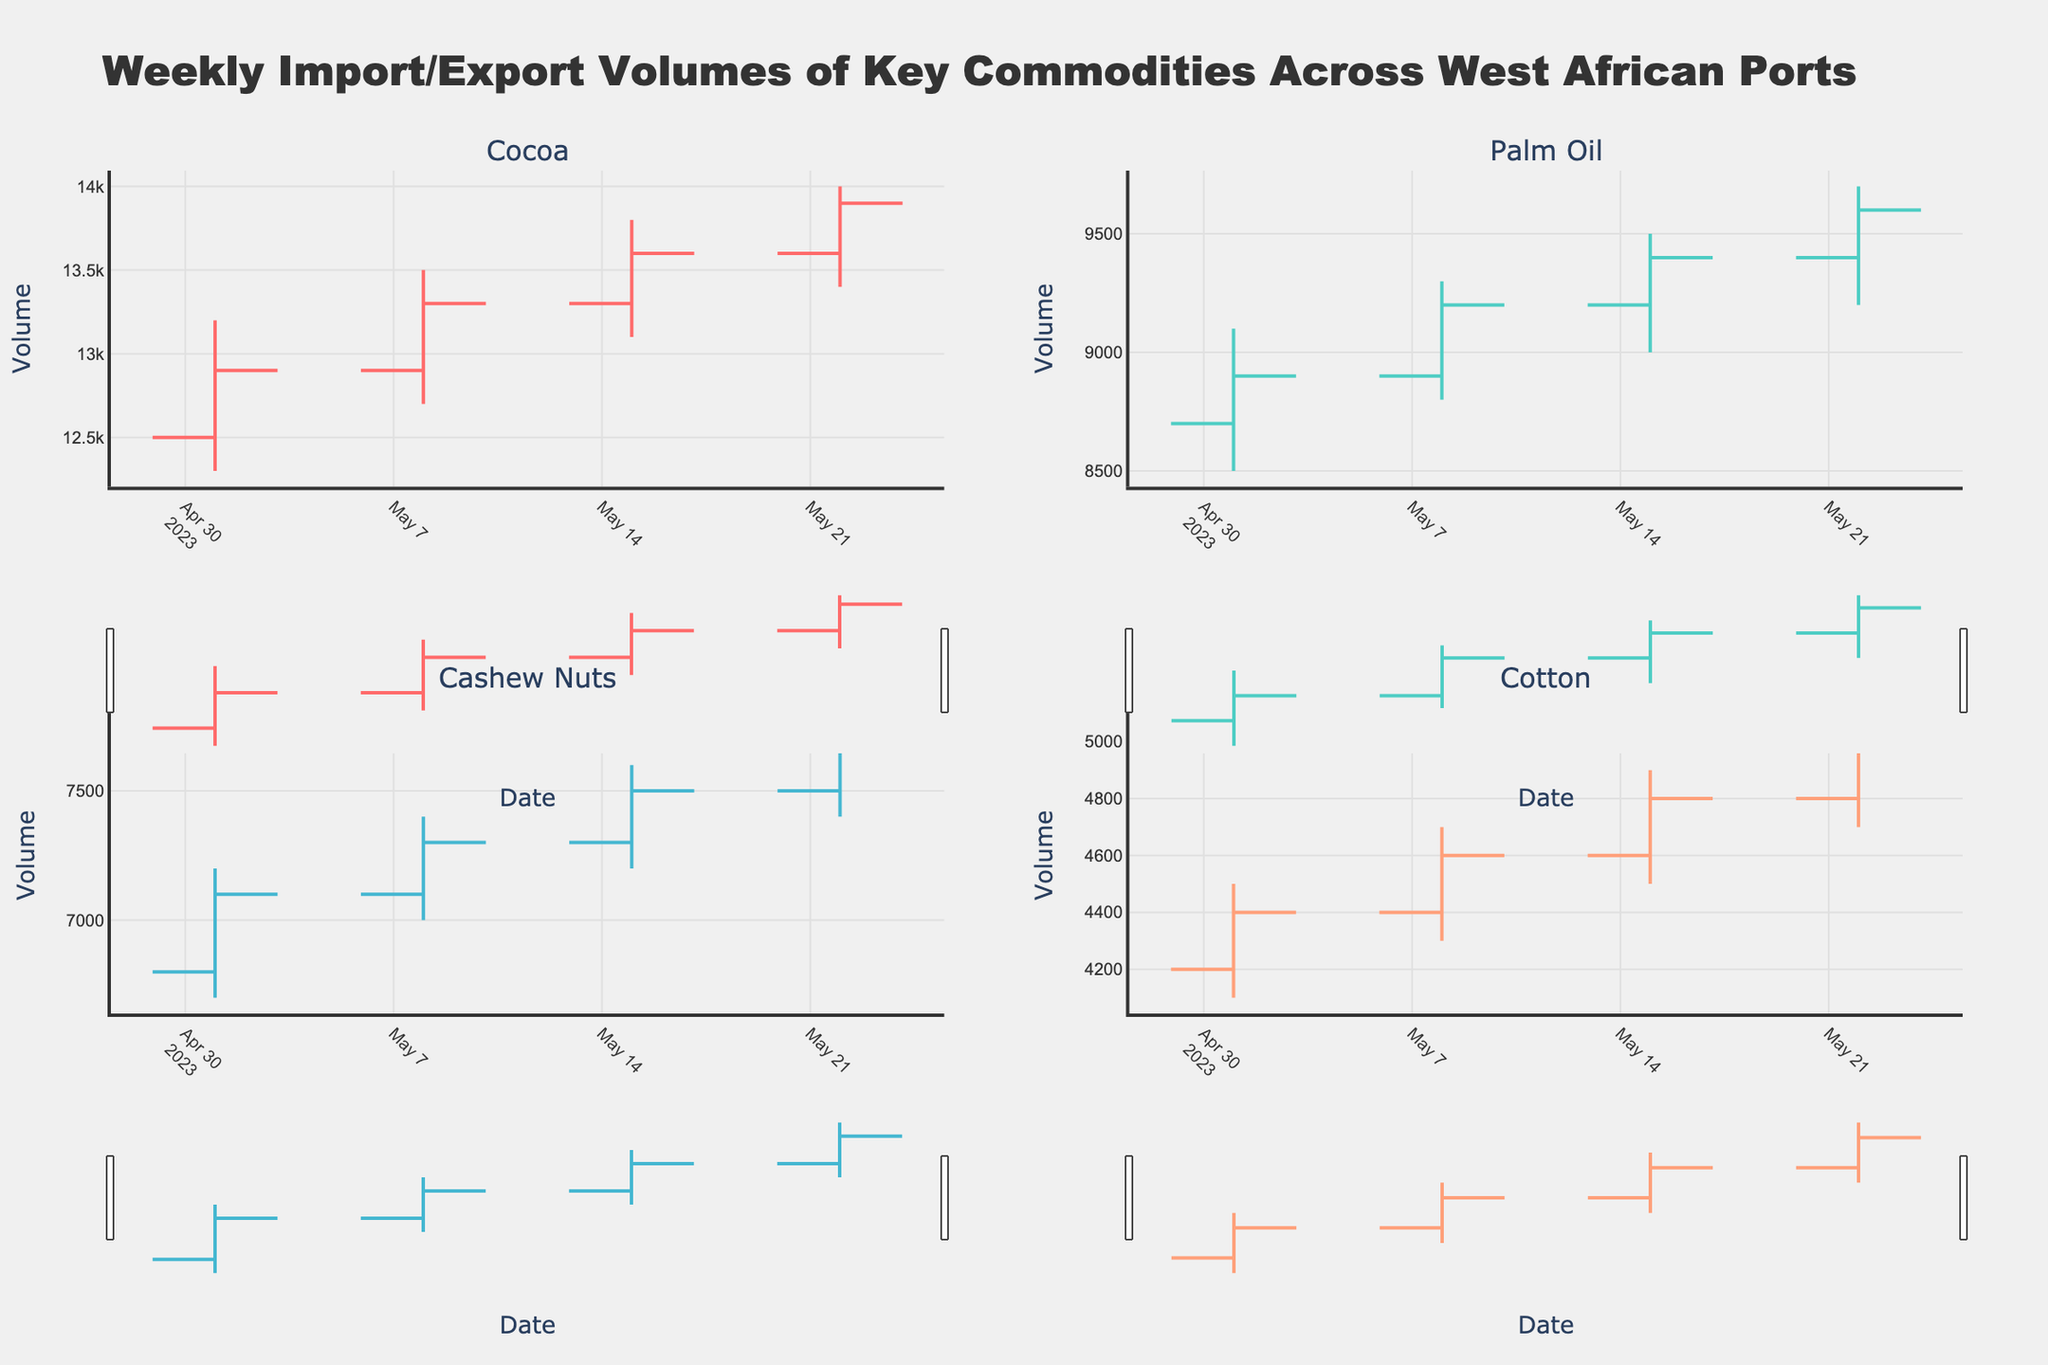What is the title of the figure? The title of the figure is displayed at the top of the chart.
Answer: Weekly Import/Export Volumes of Key Commodities Across West African Ports How many commodities are compared in the figure? There are four separate OHLC charts, each titled with the name of a commodity.
Answer: Four Which commodity has the highest closing volume on May 22, 2023? Look at the closing volumes for each commodity on the date May 22, 2023, and find the highest value.
Answer: Cocoa Which port handles Palm Oil according to the figure? Each chart's title includes the name of the commodity and the port. For Palm Oil, the port is mentioned there.
Answer: Port of Lagos Compare the closing volumes of Cocoa on May 1 and May 22, 2023. Which date had a higher closing volume? Look at the closing volumes for Cocoa on May 1 and May 22, 2023, and compare the values.
Answer: May 22, 2023 Calculate the range of the volumes for Cotton on May 8, 2023. The range is calculated by subtracting the low volume from the high volume on that date for Cotton. The formula is Range = High - Low = 4700 - 4300.
Answer: 400 Which commodity shows an increasing trend every week throughout May 2023? Identify the commodity whose closing volume increases consistently from one week to the next.
Answer: Cashew Nuts Between April 24, 2023, and May 22, 2023, which commodity had the greatest increase in closing volume at the Port of Lomé? Calculate the difference in closing volumes for each week for Cotton, and identify the week with the highest increase.
Answer: Cotton Which commodity had a decreasing trend on May 1, 2023? Identify the commodity where the closing volume is less than the opening volume on that date.
Answer: None What is the average closing volume for Palm Oil across all dates? Sum the closing volumes of Palm Oil for all dates provided and divide by the number of dates: (8900 + 9200 + 9400 + 9600) / 4.
Answer: 9275 